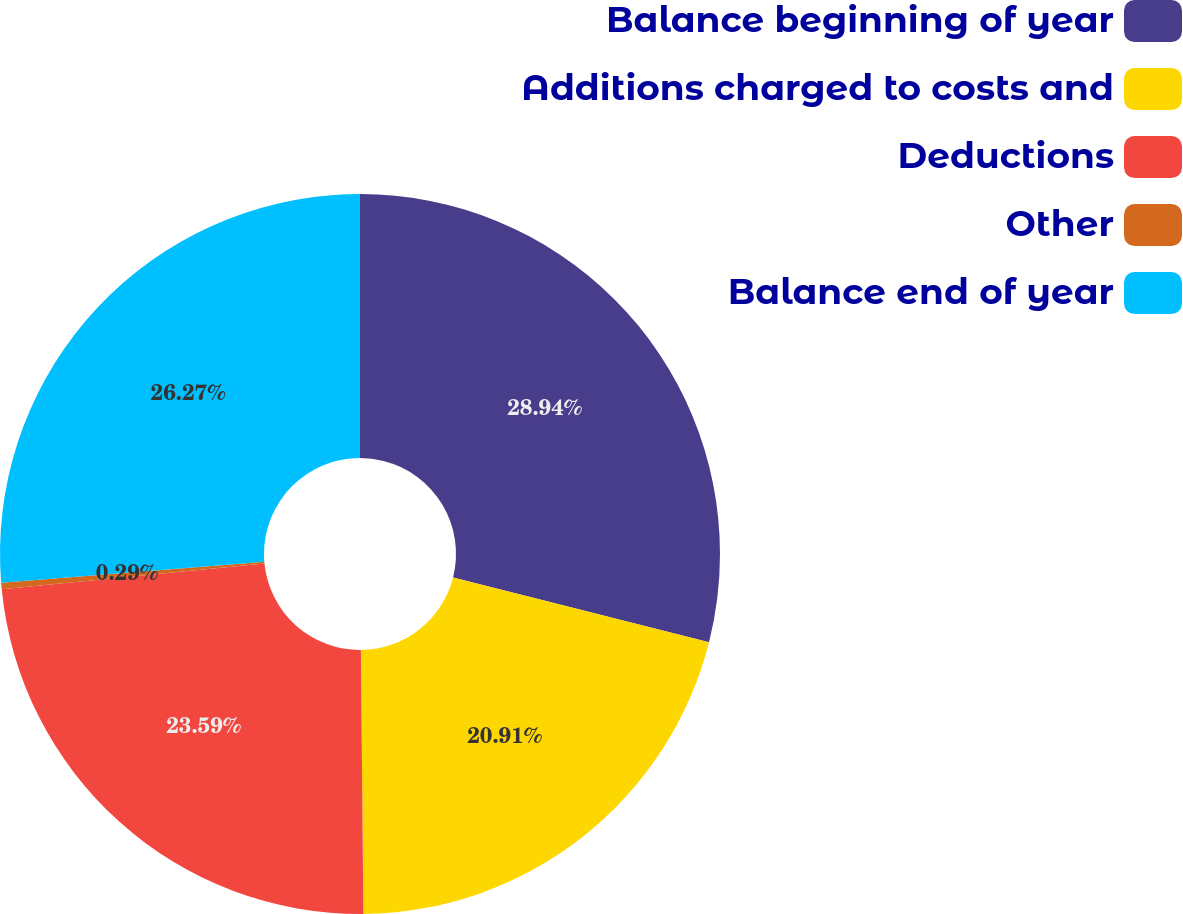<chart> <loc_0><loc_0><loc_500><loc_500><pie_chart><fcel>Balance beginning of year<fcel>Additions charged to costs and<fcel>Deductions<fcel>Other<fcel>Balance end of year<nl><fcel>28.94%<fcel>20.91%<fcel>23.59%<fcel>0.29%<fcel>26.27%<nl></chart> 